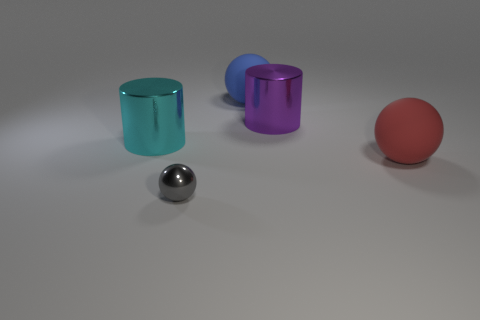Is there anything else that has the same size as the cyan metal object?
Your response must be concise. Yes. Is there another large cyan object that has the same shape as the cyan object?
Your response must be concise. No. The rubber thing that is the same size as the red sphere is what color?
Keep it short and to the point. Blue. What is the size of the gray shiny sphere to the right of the large cyan cylinder?
Offer a very short reply. Small. Are there any matte balls that are in front of the ball behind the red object?
Provide a short and direct response. Yes. Do the ball that is to the right of the blue sphere and the big purple cylinder have the same material?
Your answer should be compact. No. How many objects are left of the blue thing and in front of the large cyan metal cylinder?
Keep it short and to the point. 1. How many big blue balls have the same material as the large cyan cylinder?
Your response must be concise. 0. What is the color of the large thing that is the same material as the red ball?
Make the answer very short. Blue. Is the number of tiny cyan metal cubes less than the number of cylinders?
Give a very brief answer. Yes. 